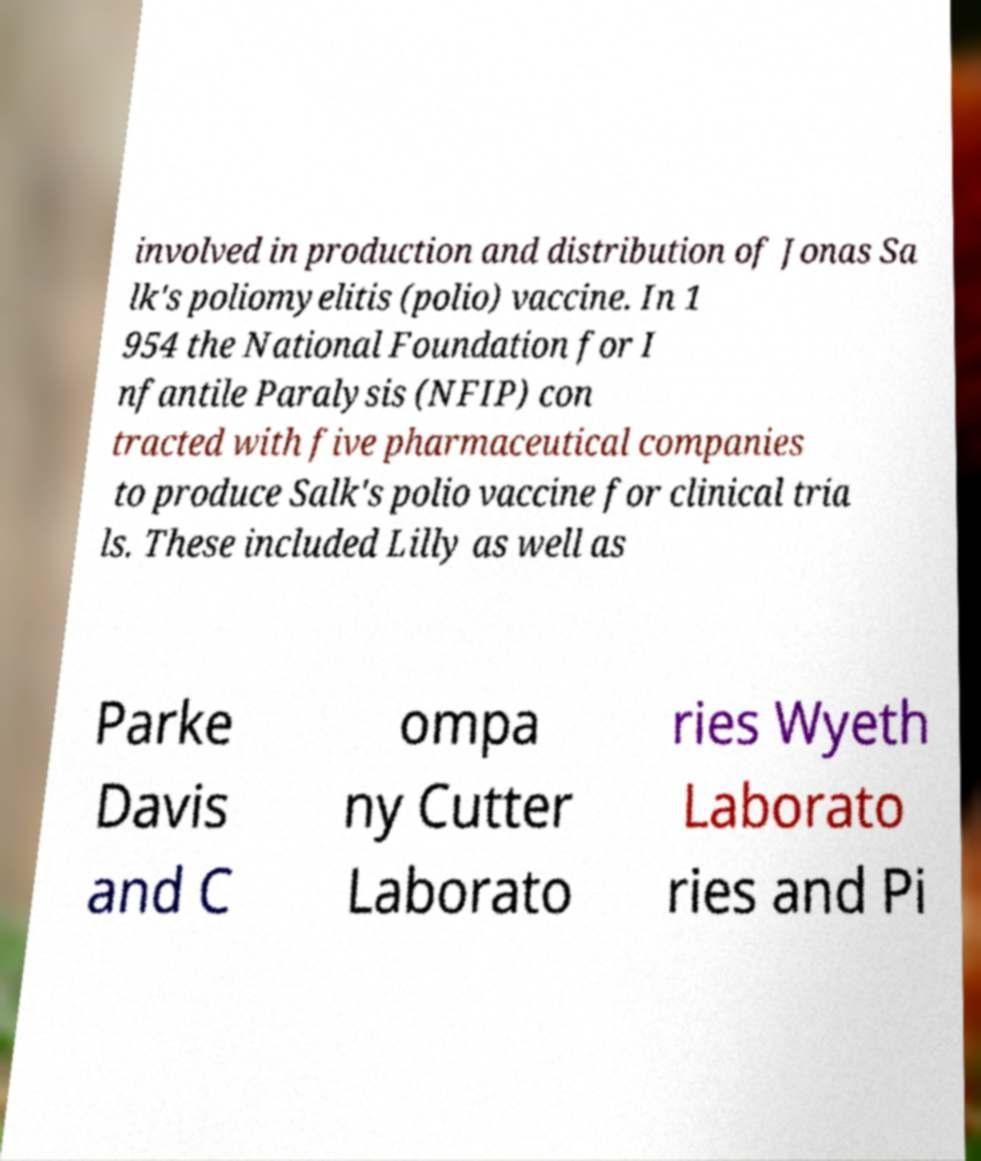What messages or text are displayed in this image? I need them in a readable, typed format. involved in production and distribution of Jonas Sa lk's poliomyelitis (polio) vaccine. In 1 954 the National Foundation for I nfantile Paralysis (NFIP) con tracted with five pharmaceutical companies to produce Salk's polio vaccine for clinical tria ls. These included Lilly as well as Parke Davis and C ompa ny Cutter Laborato ries Wyeth Laborato ries and Pi 